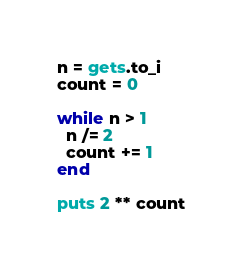<code> <loc_0><loc_0><loc_500><loc_500><_Ruby_>n = gets.to_i
count = 0

while n > 1
  n /= 2
  count += 1
end

puts 2 ** count</code> 